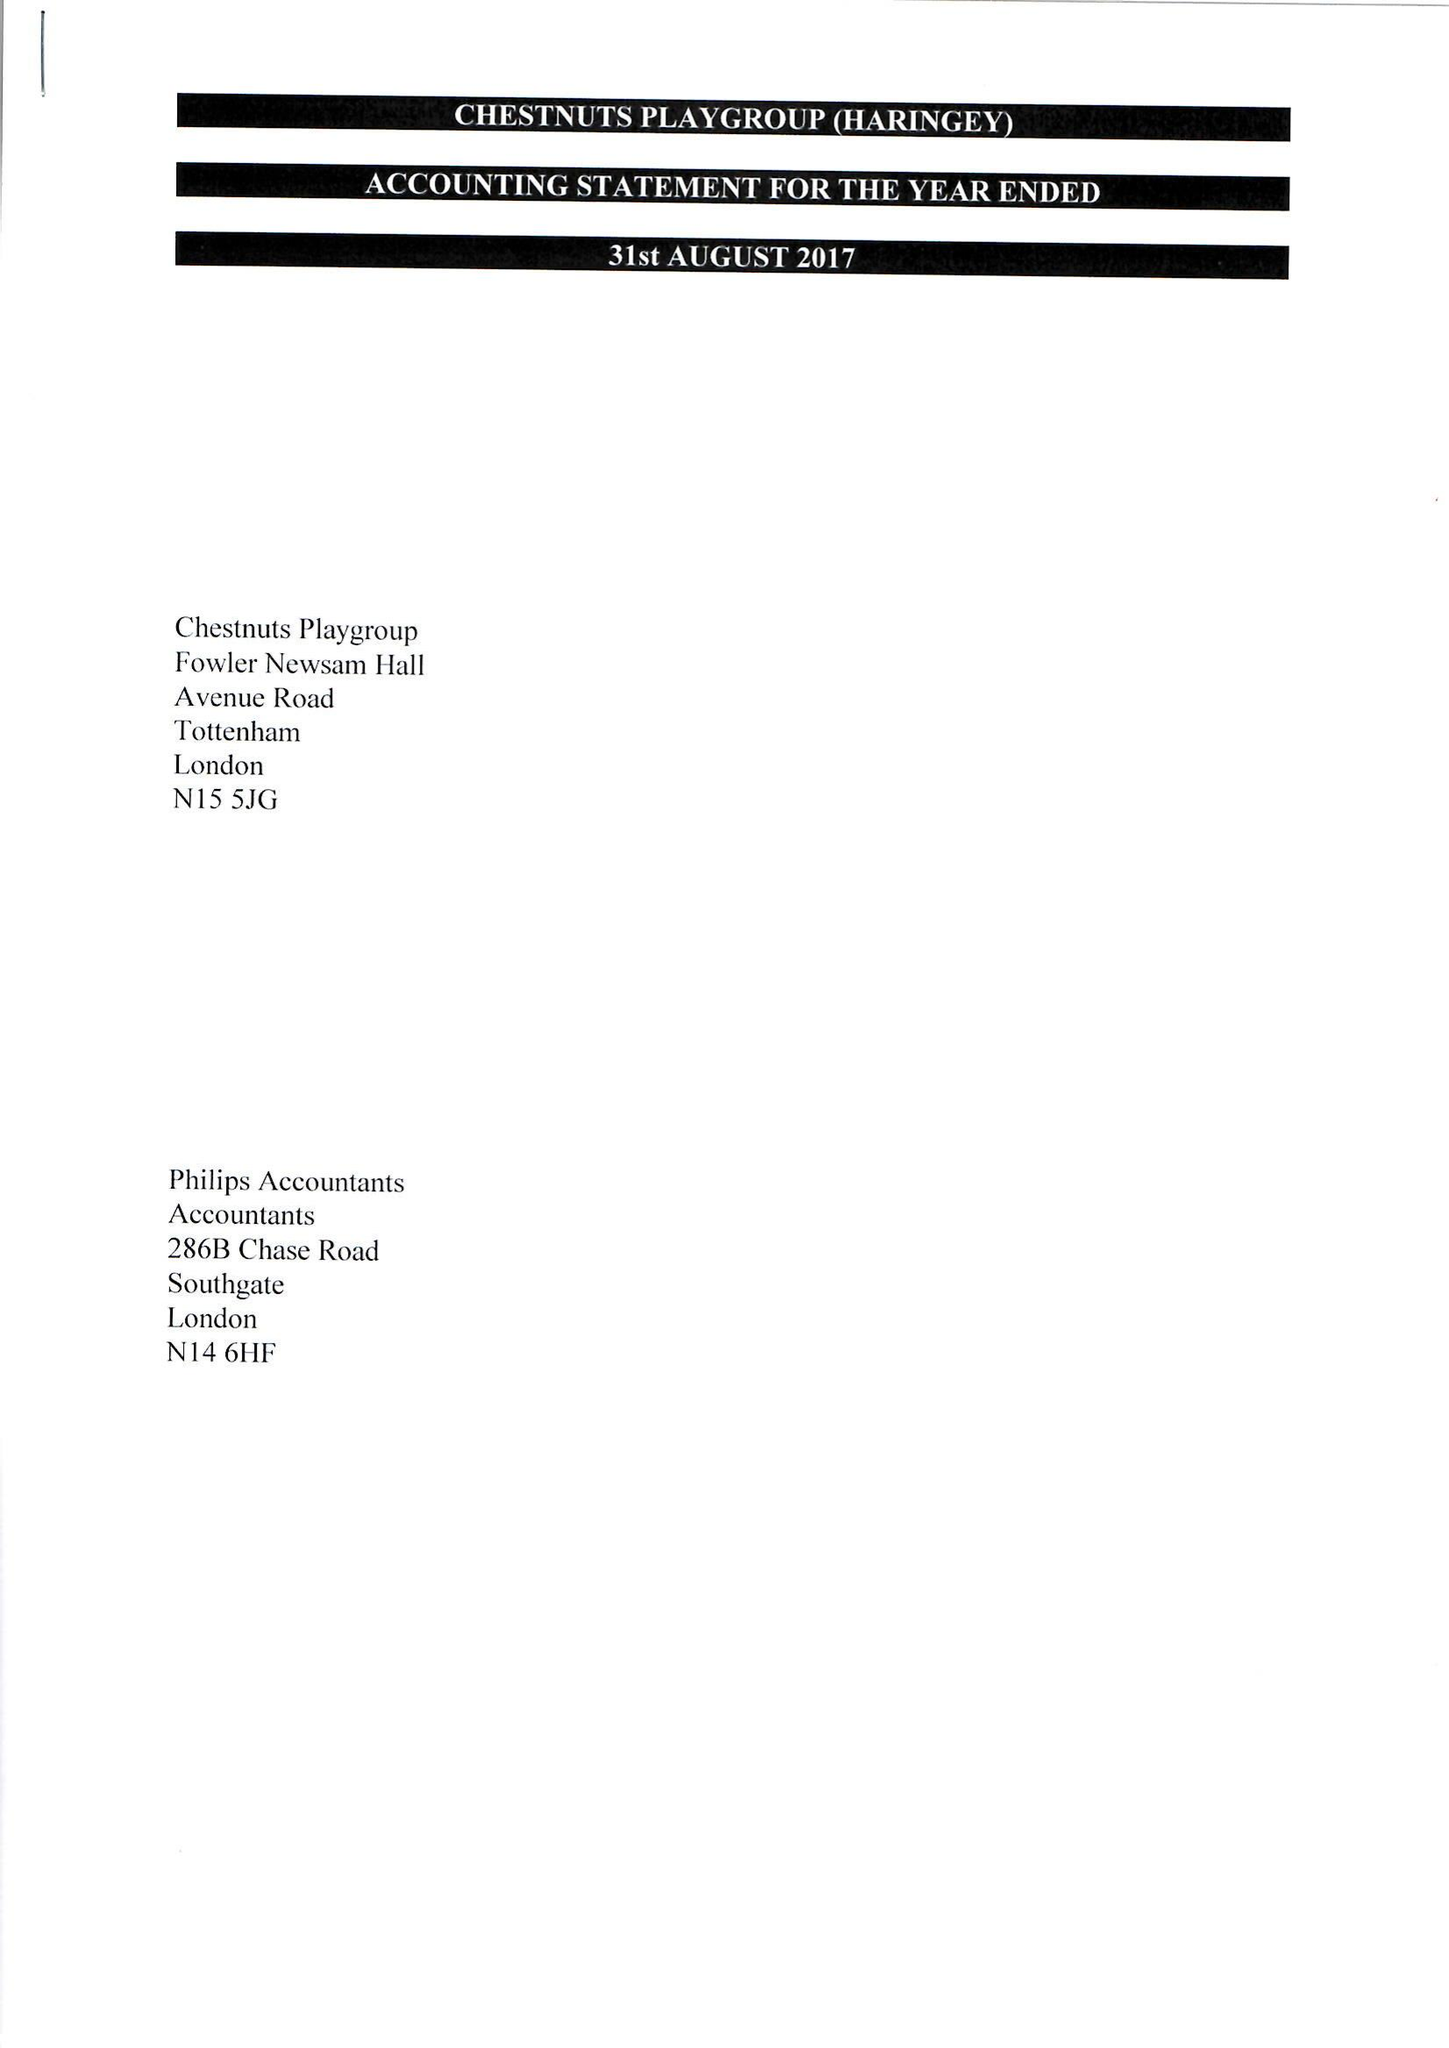What is the value for the address__post_town?
Answer the question using a single word or phrase. LONDON 